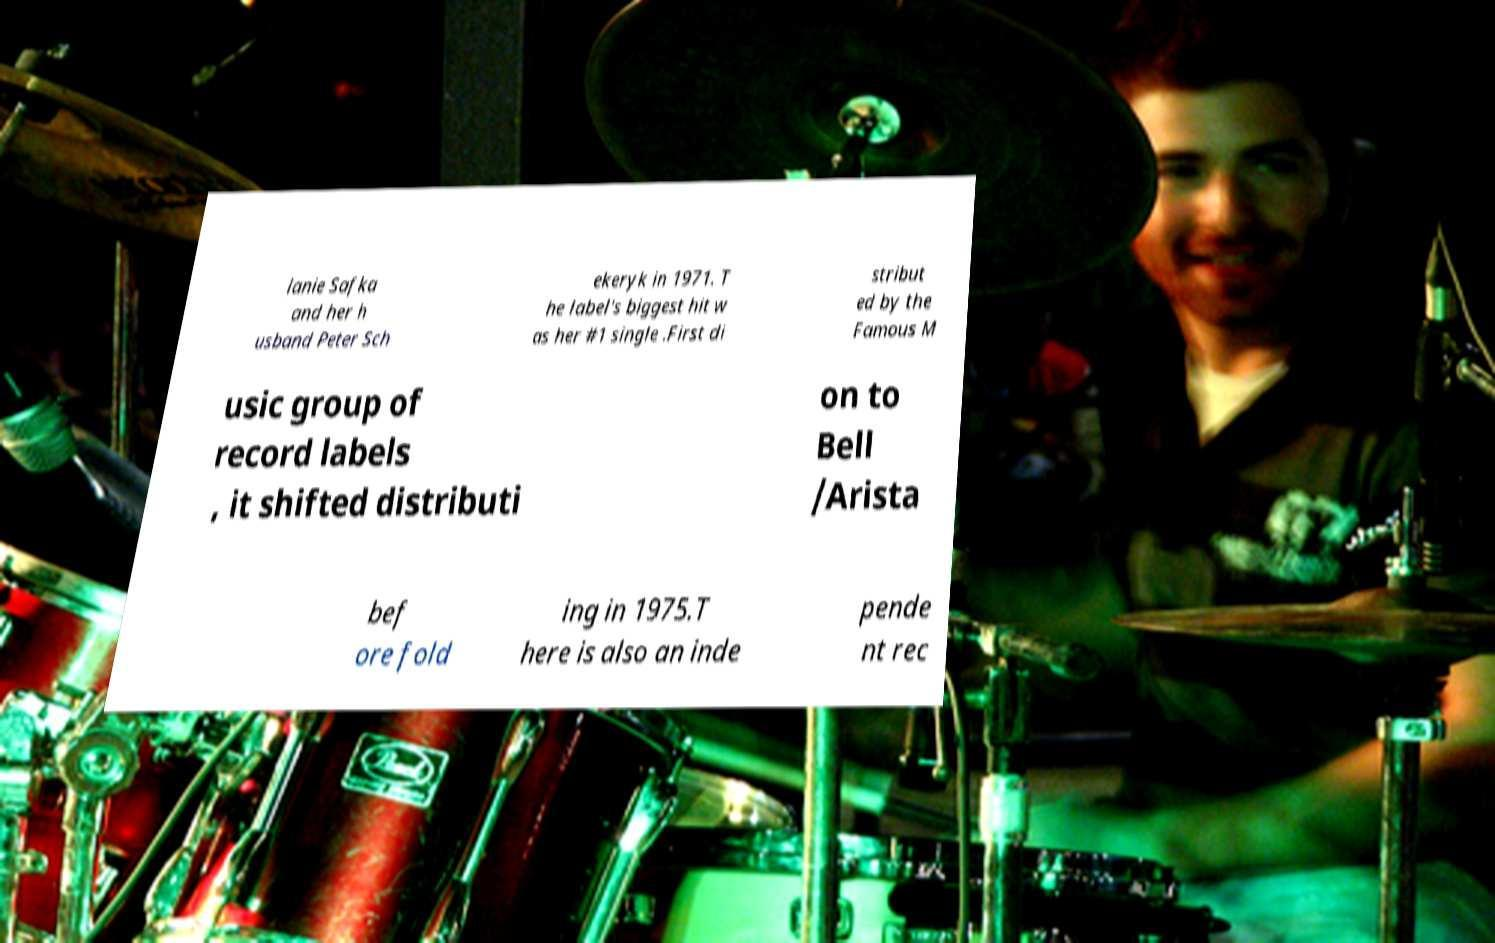Could you extract and type out the text from this image? lanie Safka and her h usband Peter Sch ekeryk in 1971. T he label's biggest hit w as her #1 single .First di stribut ed by the Famous M usic group of record labels , it shifted distributi on to Bell /Arista bef ore fold ing in 1975.T here is also an inde pende nt rec 